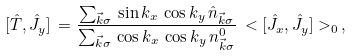<formula> <loc_0><loc_0><loc_500><loc_500>[ \hat { T } , \hat { J } _ { y } ] \, = \frac { \sum _ { \vec { k } \sigma } \, \sin k _ { x } \, \cos k _ { y } \, \hat { n } _ { \vec { k } \sigma } } { \sum _ { \vec { k } \sigma } \, \cos k _ { x } \, \cos k _ { y } \, n _ { \vec { k } \sigma } ^ { 0 } } \, < [ \hat { J } _ { x } , \hat { J } _ { y } ] > _ { 0 } \, ,</formula> 